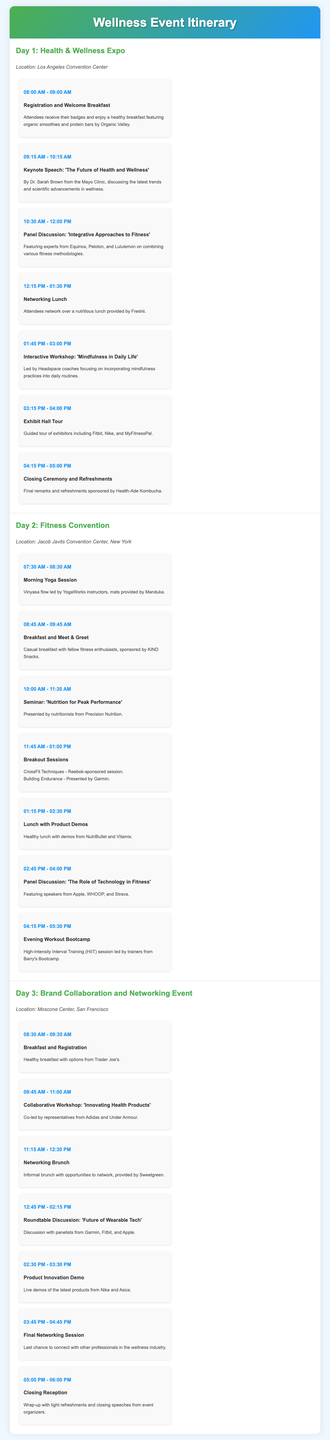what is the location of Day 1 event? The location for Day 1 is provided in the event itinerary, specifically mentioning the Los Angeles Convention Center.
Answer: Los Angeles Convention Center who is the keynote speaker for Day 1? The document specifies that Dr. Sarah Brown from the Mayo Clinic will deliver the keynote speech.
Answer: Dr. Sarah Brown what time does the networking lunch start on Day 1? The itinerary indicates that the networking lunch on Day 1 starts at 12:15 PM.
Answer: 12:15 PM which brand sponsors the evening workout bootcamp on Day 2? The itinerary states that the HIIT session is led by trainers from Barry's Bootcamp.
Answer: Barry's Bootcamp how many workshop activities are scheduled on Day 3? The document outlines that there are three workshop activities on Day 3: Collaborative Workshop, Roundtable Discussion, and Product Innovation Demo.
Answer: Three what is the title of the panel discussion on Day 2? The panel discussion title provided in the itinerary is 'The Role of Technology in Fitness'.
Answer: The Role of Technology in Fitness what is the last scheduled event of the itinerary? The itinerary details that the last scheduled event is the Closing Reception on Day 3.
Answer: Closing Reception which brand provides the breakfast on Day 3? The document mentions that Trader Joe's provides the healthy breakfast on Day 3.
Answer: Trader Joe's how long is the exhibit hall tour on Day 1? The document specifies that the Exhibit Hall Tour on Day 1 lasts for 45 minutes, from 3:15 PM to 4:00 PM.
Answer: 45 minutes 